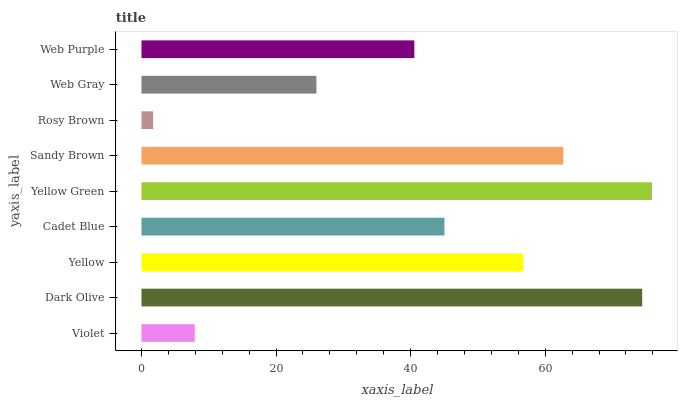Is Rosy Brown the minimum?
Answer yes or no. Yes. Is Yellow Green the maximum?
Answer yes or no. Yes. Is Dark Olive the minimum?
Answer yes or no. No. Is Dark Olive the maximum?
Answer yes or no. No. Is Dark Olive greater than Violet?
Answer yes or no. Yes. Is Violet less than Dark Olive?
Answer yes or no. Yes. Is Violet greater than Dark Olive?
Answer yes or no. No. Is Dark Olive less than Violet?
Answer yes or no. No. Is Cadet Blue the high median?
Answer yes or no. Yes. Is Cadet Blue the low median?
Answer yes or no. Yes. Is Web Gray the high median?
Answer yes or no. No. Is Sandy Brown the low median?
Answer yes or no. No. 